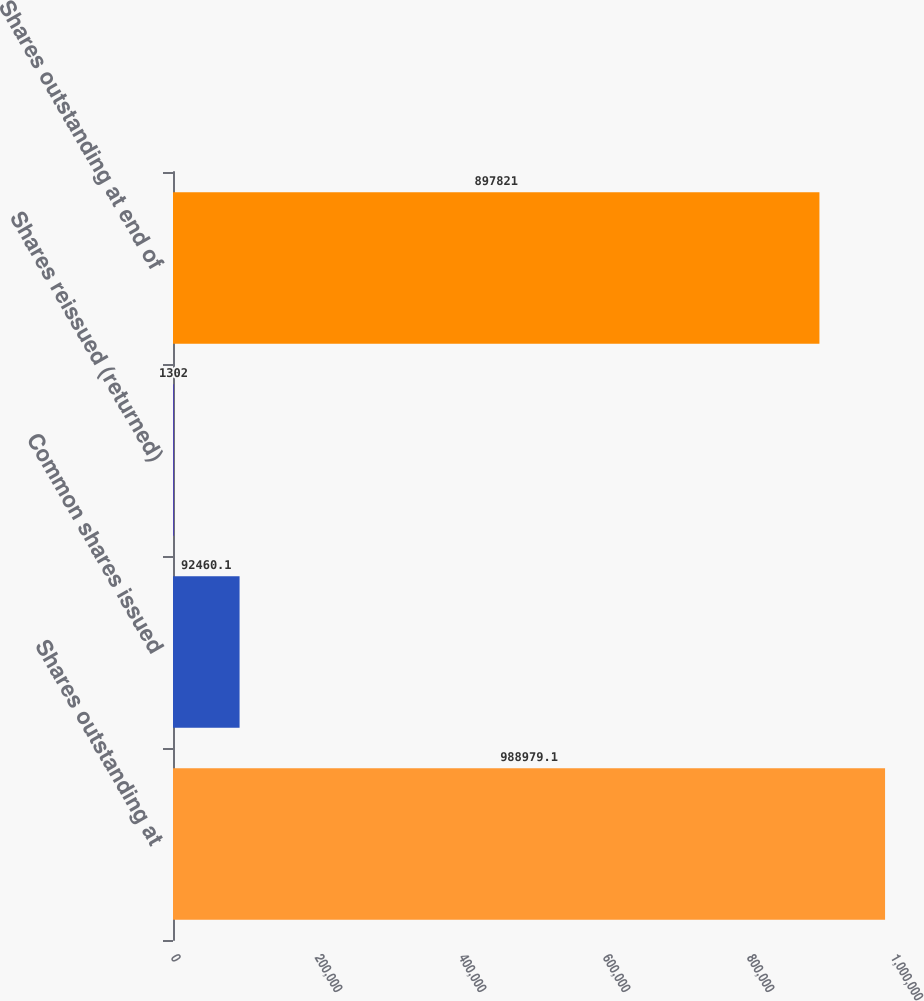Convert chart to OTSL. <chart><loc_0><loc_0><loc_500><loc_500><bar_chart><fcel>Shares outstanding at<fcel>Common shares issued<fcel>Shares reissued (returned)<fcel>Shares outstanding at end of<nl><fcel>988979<fcel>92460.1<fcel>1302<fcel>897821<nl></chart> 